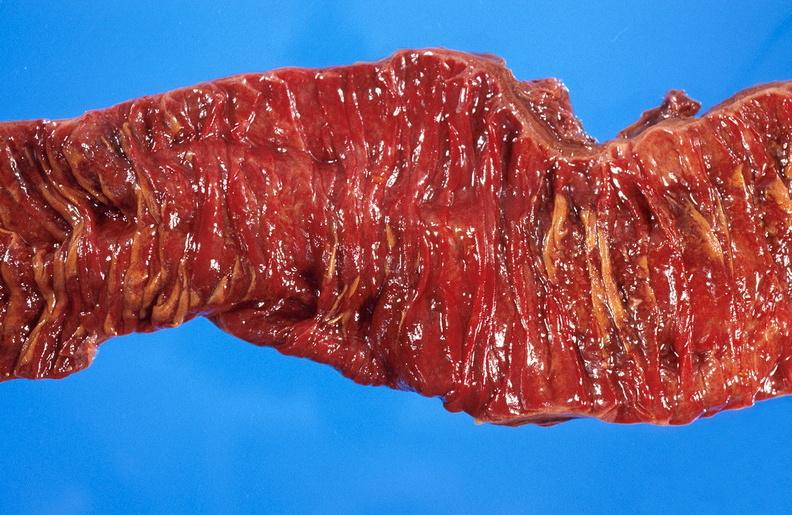where does this belong to?
Answer the question using a single word or phrase. Gastrointestinal system 